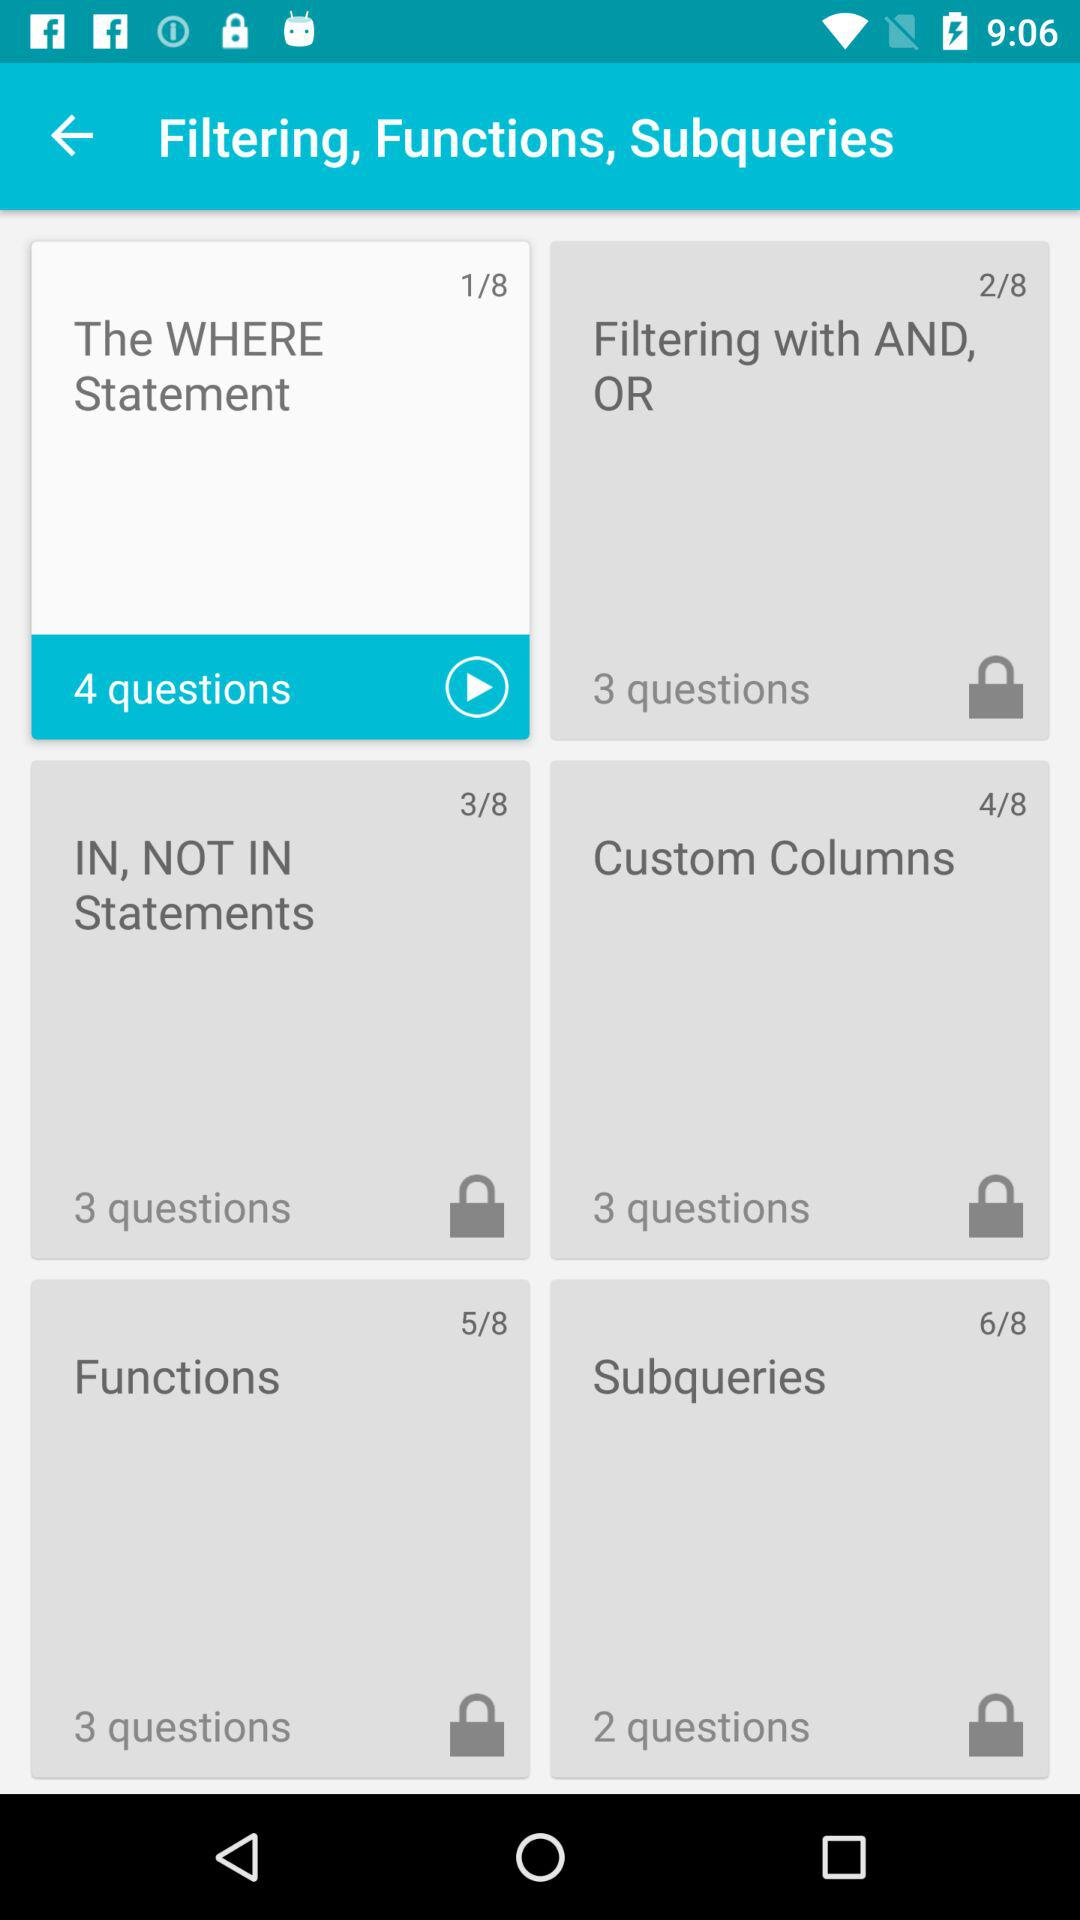How many questions are there about the WHERE statement?
Answer the question using a single word or phrase. 4 